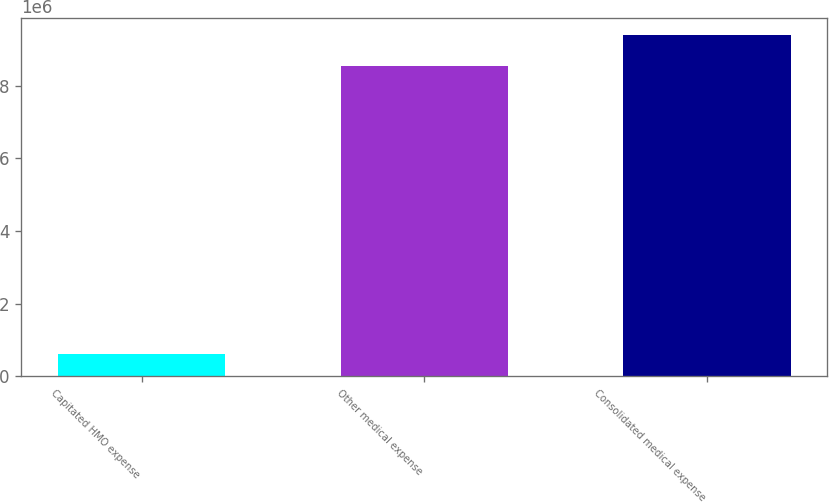Convert chart to OTSL. <chart><loc_0><loc_0><loc_500><loc_500><bar_chart><fcel>Capitated HMO expense<fcel>Other medical expense<fcel>Consolidated medical expense<nl><fcel>603617<fcel>8.53458e+06<fcel>9.38804e+06<nl></chart> 